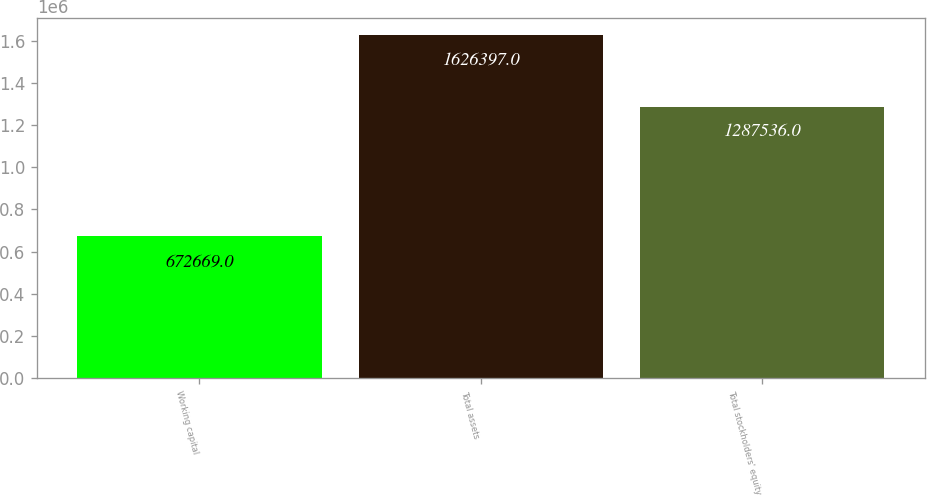Convert chart to OTSL. <chart><loc_0><loc_0><loc_500><loc_500><bar_chart><fcel>Working capital<fcel>Total assets<fcel>Total stockholders' equity<nl><fcel>672669<fcel>1.6264e+06<fcel>1.28754e+06<nl></chart> 